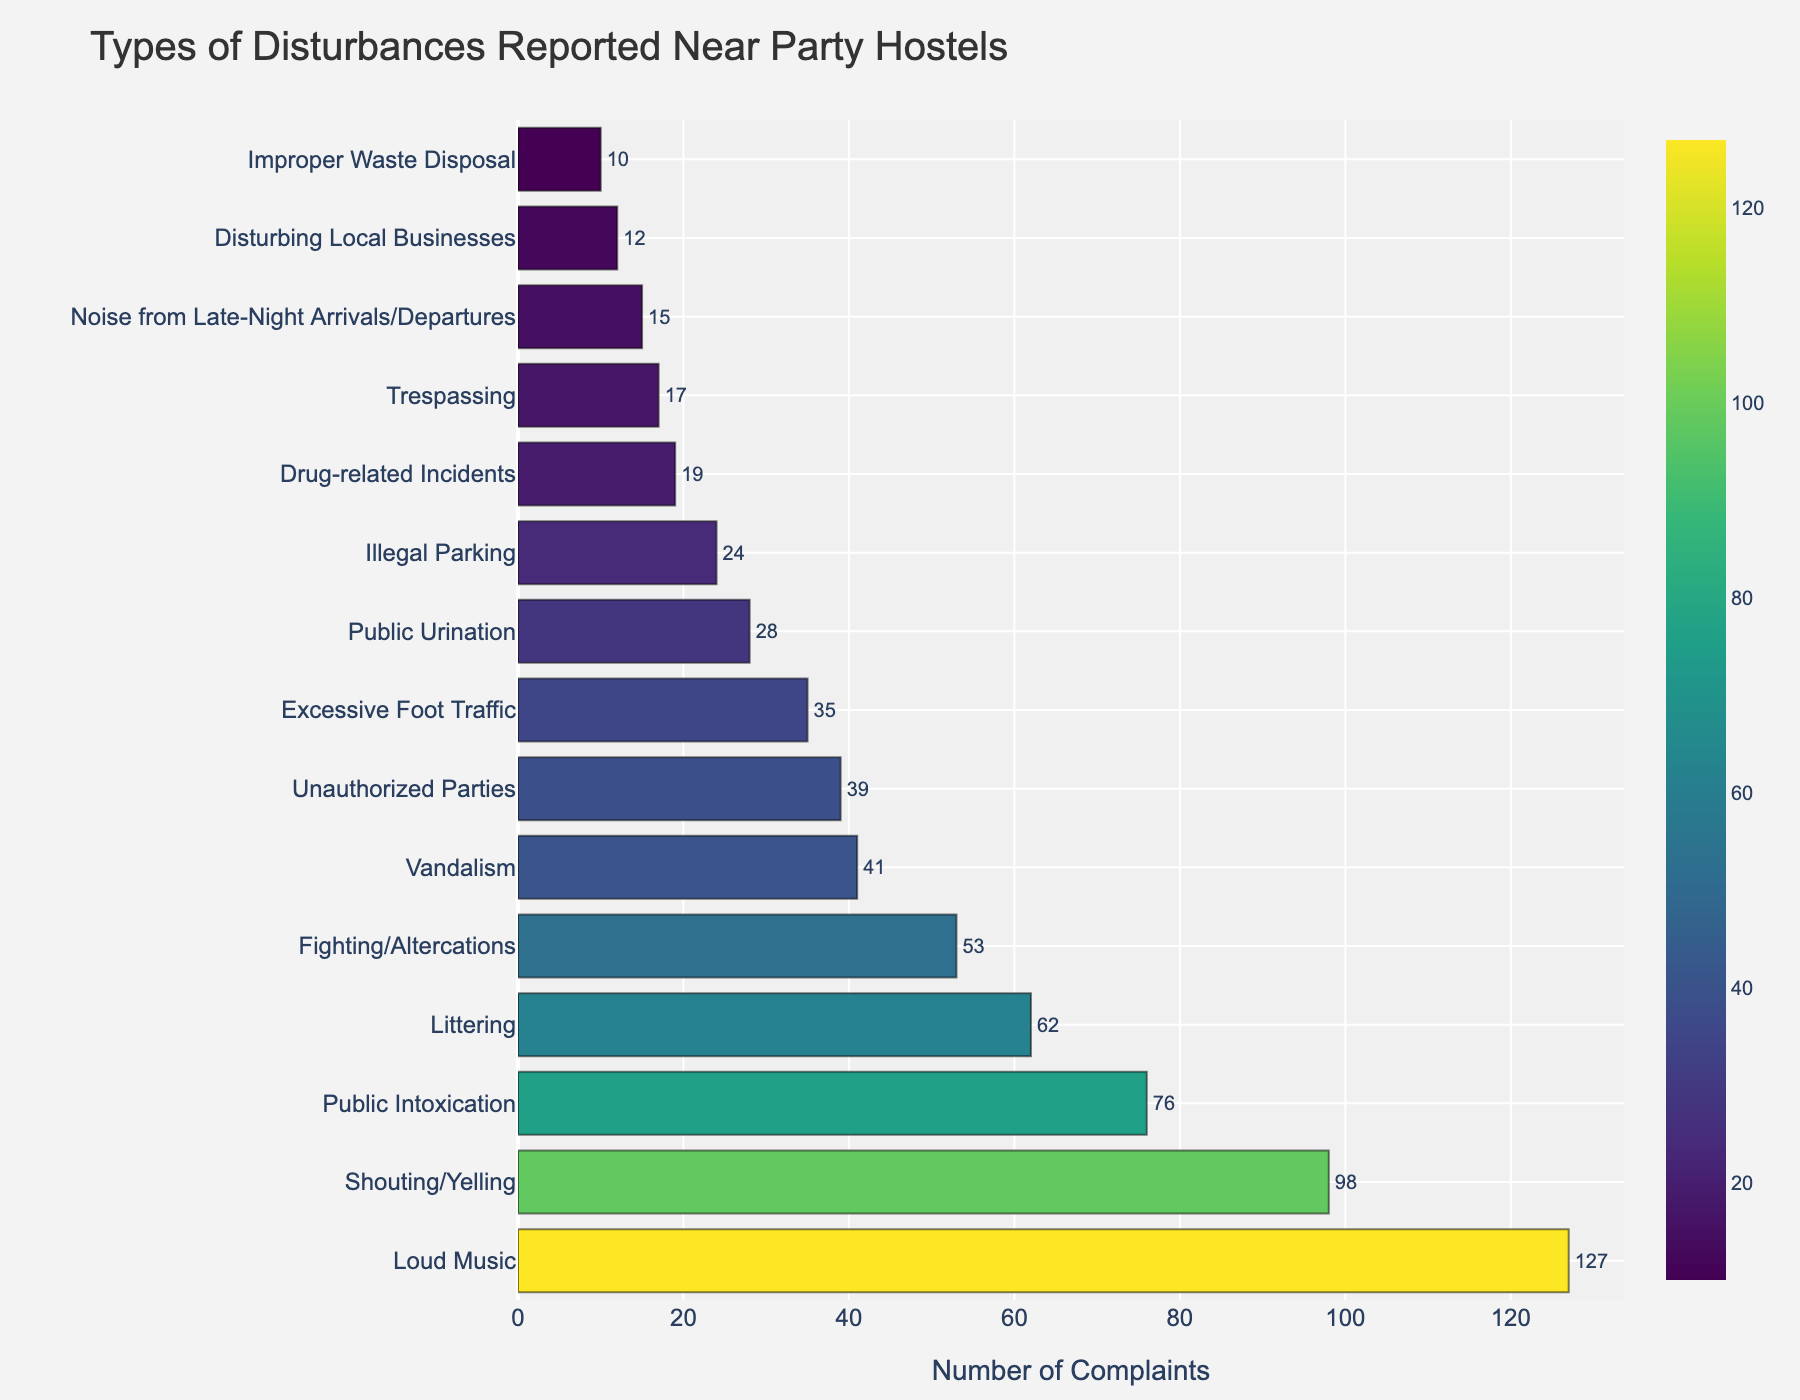Which type of disturbance has the highest number of complaints? The bar for "Loud Music" is the longest, meaning it represents the highest number of complaints.
Answer: Loud Music How many total complaints were made for Loud Music and Shouting/Yelling combined? The number of complaints for Loud Music is 127, and for Shouting/Yelling it's 98. Adding these together gives 127 + 98 = 225.
Answer: 225 Is Public Intoxication a more common complaint than Vandalism? The bar for Public Intoxication is longer than the bar for Vandalism, indicating more complaints for Public Intoxication.
Answer: Yes Which disturbance has fewer complaints, Littering or Fighting/Altercations? The bar for Fighting/Altercations is shorter than the bar for Littering, indicating fewer complaints.
Answer: Fighting/Altercations How many more complaints are there for Excessive Foot Traffic compared to Public Urination? Excessive Foot Traffic has 35 complaints, and Public Urination has 28. The difference is 35 - 28 = 7.
Answer: 7 What is the average number of complaints among Unauthorized Parties, Excessive Foot Traffic, and Public Urination? The numbers are 39, 35, and 28. Adding these gives 39 + 35 + 28 = 102. Dividing by 3, the average is 102 / 3 = 34.
Answer: 34 Which has more complaints: Disturbing Local Businesses or Improper Waste Disposal? The bar for Disturbing Local Businesses is longer than for Improper Waste Disposal, indicating more complaints.
Answer: Disturbing Local Businesses Are there more than 20 complaints for Illegal Parking? The bar for Illegal Parking extends beyond the 20 mark, indicating more than 20 complaints.
Answer: Yes How many complaints does Drug-related Incidents have compared to Trespassing? Drug-related Incidents have 19 complaints, and Trespassing has 17. The difference is 19 - 17 = 2.
Answer: 2 What is the median number of complaints for all disturbances? To find the median, arrange the complaint numbers in ascending order: 10, 12, 15, 17, 19, 24, 28, 35, 39, 41, 53, 62, 76, 98, 127. With 15 numbers, the median is the 8th number, which is 35.
Answer: 35 